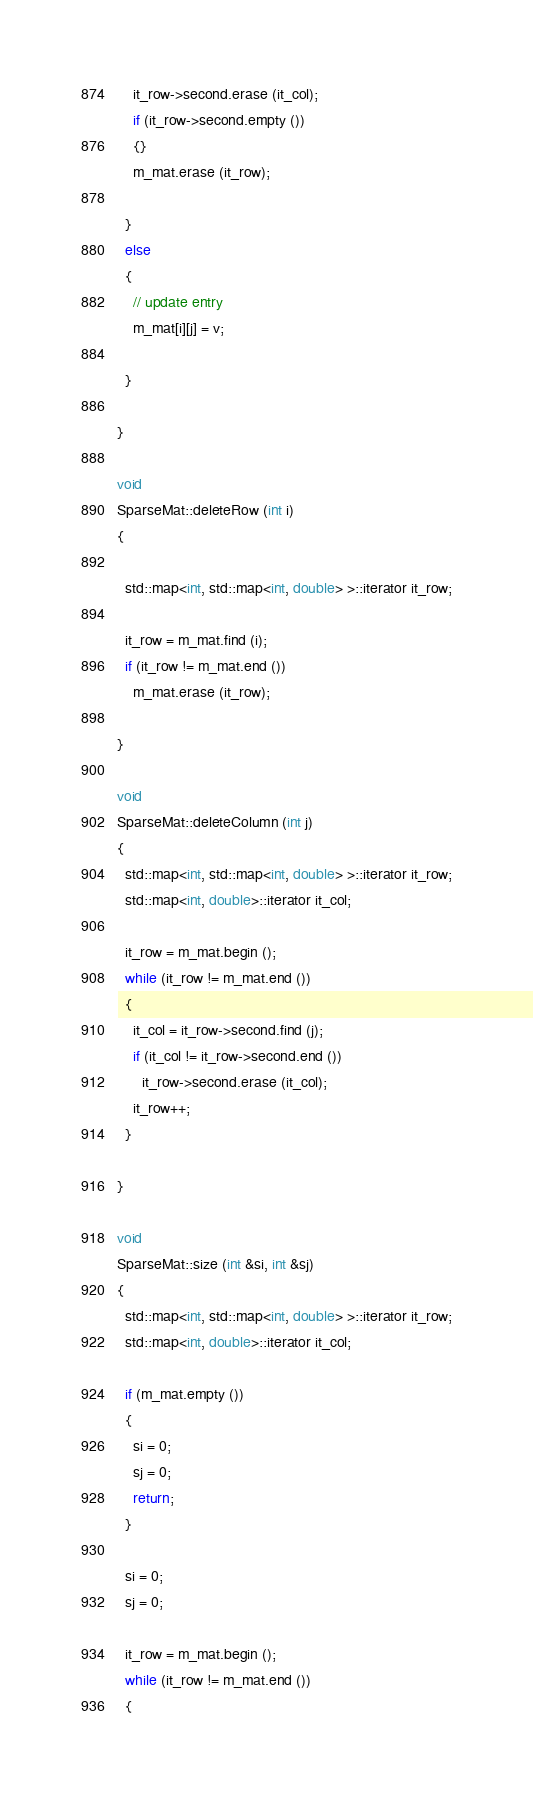Convert code to text. <code><loc_0><loc_0><loc_500><loc_500><_C++_>    it_row->second.erase (it_col);
    if (it_row->second.empty ())
    {}
    m_mat.erase (it_row);

  }
  else
  {
    // update entry
    m_mat[i][j] = v;

  }

}

void
SparseMat::deleteRow (int i)
{

  std::map<int, std::map<int, double> >::iterator it_row;

  it_row = m_mat.find (i);
  if (it_row != m_mat.end ())
    m_mat.erase (it_row);

}

void
SparseMat::deleteColumn (int j)
{
  std::map<int, std::map<int, double> >::iterator it_row;
  std::map<int, double>::iterator it_col;

  it_row = m_mat.begin ();
  while (it_row != m_mat.end ())
  {
    it_col = it_row->second.find (j);
    if (it_col != it_row->second.end ())
      it_row->second.erase (it_col);
    it_row++;
  }

}

void
SparseMat::size (int &si, int &sj)
{
  std::map<int, std::map<int, double> >::iterator it_row;
  std::map<int, double>::iterator it_col;

  if (m_mat.empty ())
  {
    si = 0;
    sj = 0;
    return;
  }

  si = 0;
  sj = 0;

  it_row = m_mat.begin ();
  while (it_row != m_mat.end ())
  {</code> 